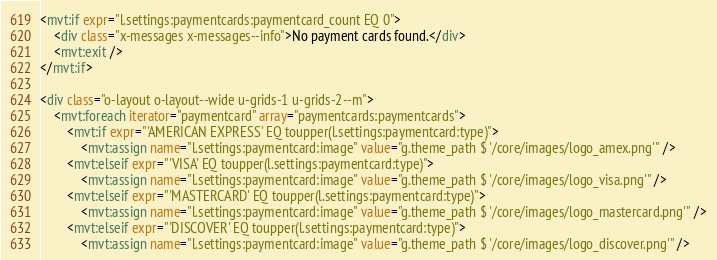<code> <loc_0><loc_0><loc_500><loc_500><_HTML_><mvt:if expr="l.settings:paymentcards:paymentcard_count EQ 0">
	<div class="x-messages x-messages--info">No payment cards found.</div>
	<mvt:exit />
</mvt:if>

<div class="o-layout o-layout--wide u-grids-1 u-grids-2--m">
	<mvt:foreach iterator="paymentcard" array="paymentcards:paymentcards">
		<mvt:if expr="'AMERICAN EXPRESS' EQ toupper(l.settings:paymentcard:type)">
			<mvt:assign name="l.settings:paymentcard:image" value="g.theme_path $ '/core/images/logo_amex.png'" />
		<mvt:elseif expr="'VISA' EQ toupper(l.settings:paymentcard:type)">
			<mvt:assign name="l.settings:paymentcard:image" value="g.theme_path $ '/core/images/logo_visa.png'" />
		<mvt:elseif expr="'MASTERCARD' EQ toupper(l.settings:paymentcard:type)">
			<mvt:assign name="l.settings:paymentcard:image" value="g.theme_path $ '/core/images/logo_mastercard.png'" />
		<mvt:elseif expr="'DISCOVER' EQ toupper(l.settings:paymentcard:type)">
			<mvt:assign name="l.settings:paymentcard:image" value="g.theme_path $ '/core/images/logo_discover.png'" /></code> 